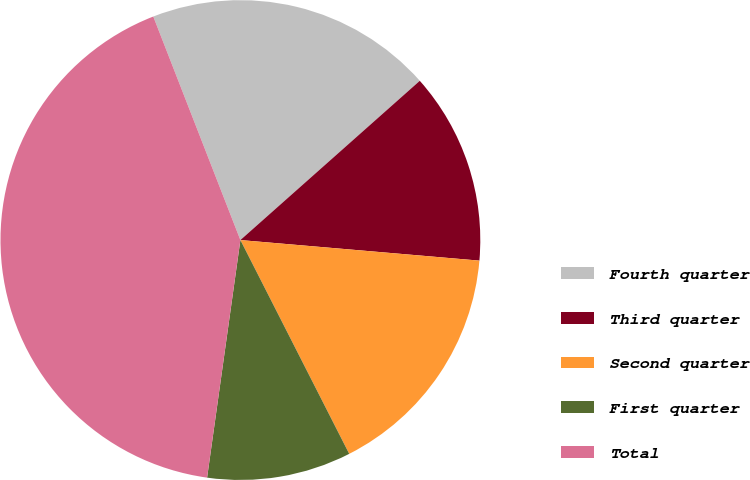Convert chart to OTSL. <chart><loc_0><loc_0><loc_500><loc_500><pie_chart><fcel>Fourth quarter<fcel>Third quarter<fcel>Second quarter<fcel>First quarter<fcel>Total<nl><fcel>19.36%<fcel>12.92%<fcel>16.14%<fcel>9.71%<fcel>41.87%<nl></chart> 